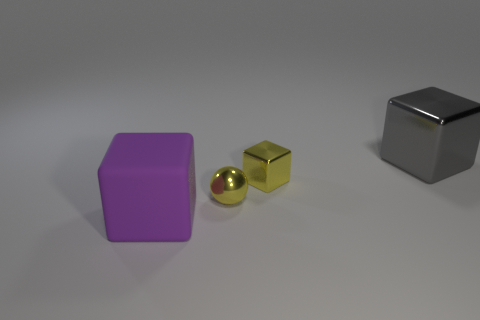There is a cube that is both behind the purple rubber thing and to the left of the large gray cube; what is its color?
Offer a terse response. Yellow. There is a big thing in front of the gray block; what is its shape?
Provide a short and direct response. Cube. There is a big gray thing that is the same material as the tiny sphere; what shape is it?
Provide a succinct answer. Cube. How many metal objects are either big gray things or small purple cylinders?
Offer a terse response. 1. There is a large block that is left of the large cube behind the purple object; how many cubes are on the right side of it?
Ensure brevity in your answer.  2. Do the yellow sphere that is to the left of the small shiny cube and the cube in front of the tiny metallic sphere have the same size?
Keep it short and to the point. No. There is a small yellow object that is the same shape as the large purple matte object; what is it made of?
Ensure brevity in your answer.  Metal. How many small things are either purple things or purple cylinders?
Your response must be concise. 0. What is the material of the large purple cube?
Offer a terse response. Rubber. There is a large metal thing; is it the same color as the big thing on the left side of the tiny yellow sphere?
Offer a very short reply. No. 